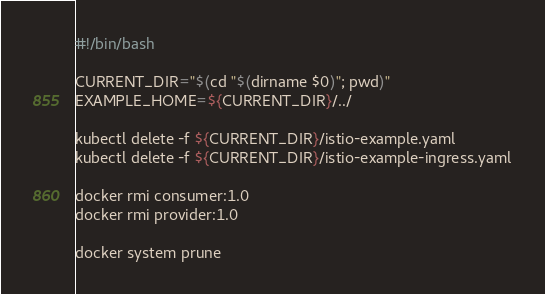Convert code to text. <code><loc_0><loc_0><loc_500><loc_500><_Bash_>#!/bin/bash

CURRENT_DIR="$(cd "$(dirname $0)"; pwd)"
EXAMPLE_HOME=${CURRENT_DIR}/../

kubectl delete -f ${CURRENT_DIR}/istio-example.yaml
kubectl delete -f ${CURRENT_DIR}/istio-example-ingress.yaml

docker rmi consumer:1.0
docker rmi provider:1.0

docker system prune</code> 